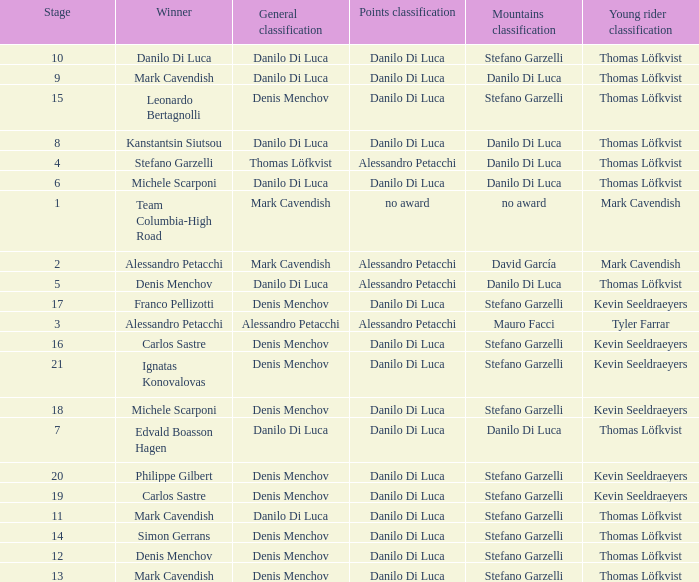When thomas löfkvist is the  young rider classification and alessandro petacchi is the points classification who are the general classifications?  Thomas Löfkvist, Danilo Di Luca. 